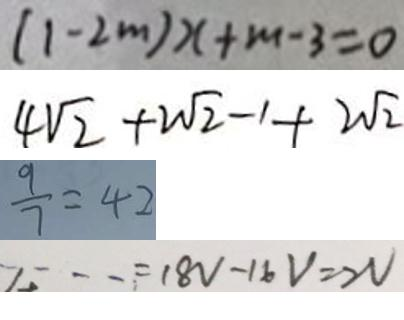<formula> <loc_0><loc_0><loc_500><loc_500>( 1 - 2 m ) x + m - 3 = 0 
 4 \sqrt { 2 } + 2 \sqrt { 2 } - 1 + 2 \sqrt { 2 } 
 \frac { 9 } { 7 } = 4 2 
 \cdots = 1 8 V - 1 6 V = 2 V</formula> 